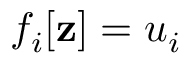Convert formula to latex. <formula><loc_0><loc_0><loc_500><loc_500>f _ { i } [ z ] = u _ { i }</formula> 